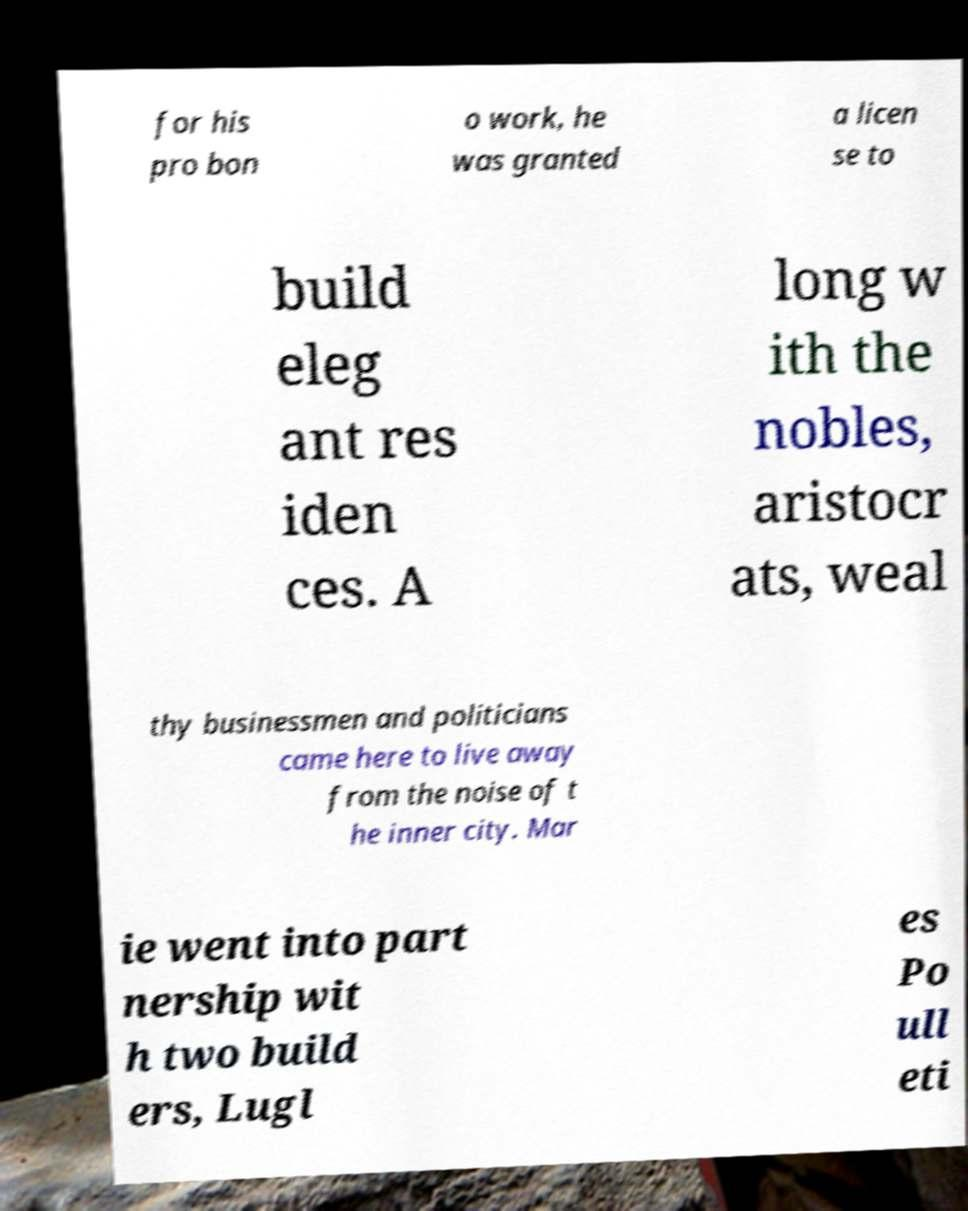Please identify and transcribe the text found in this image. for his pro bon o work, he was granted a licen se to build eleg ant res iden ces. A long w ith the nobles, aristocr ats, weal thy businessmen and politicians came here to live away from the noise of t he inner city. Mar ie went into part nership wit h two build ers, Lugl es Po ull eti 